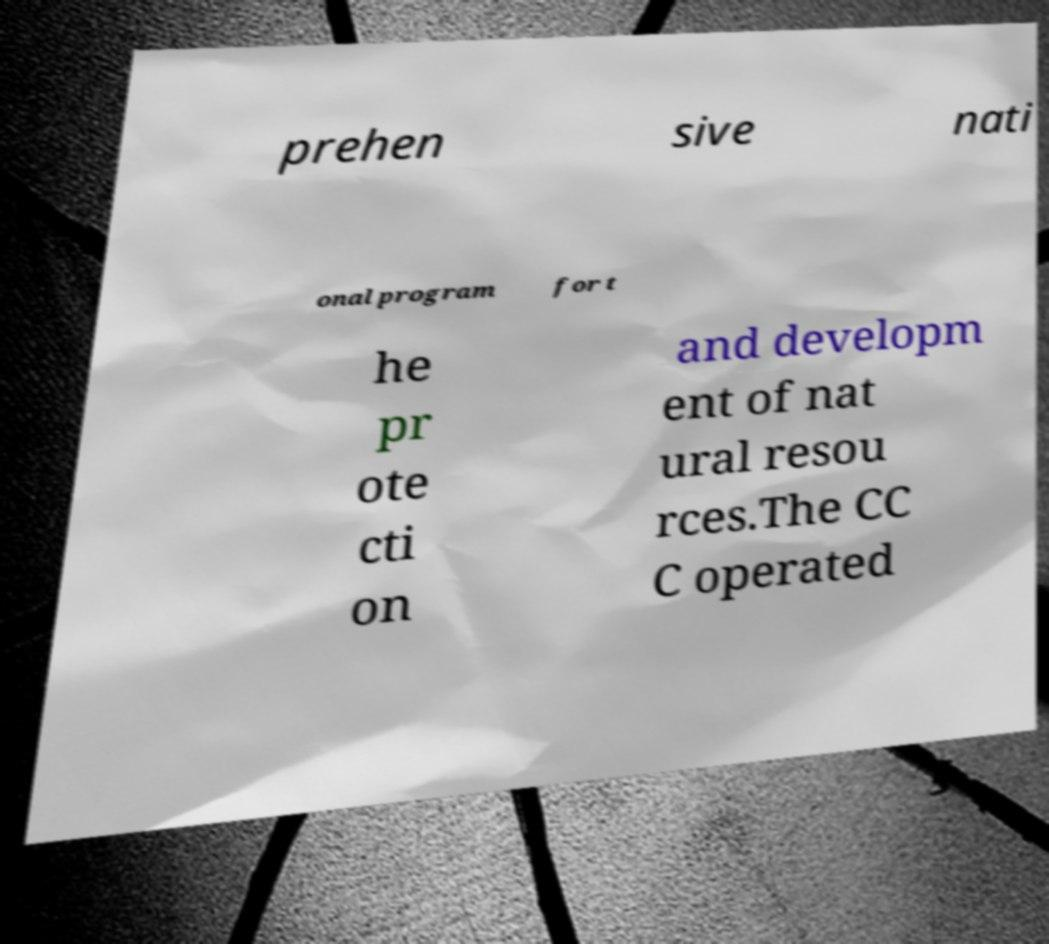Please identify and transcribe the text found in this image. prehen sive nati onal program for t he pr ote cti on and developm ent of nat ural resou rces.The CC C operated 